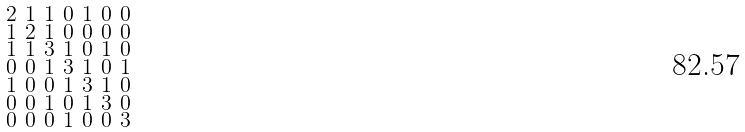<formula> <loc_0><loc_0><loc_500><loc_500>\begin{smallmatrix} 2 & 1 & 1 & 0 & 1 & 0 & 0 \\ 1 & 2 & 1 & 0 & 0 & 0 & 0 \\ 1 & 1 & 3 & 1 & 0 & 1 & 0 \\ 0 & 0 & 1 & 3 & 1 & 0 & 1 \\ 1 & 0 & 0 & 1 & 3 & 1 & 0 \\ 0 & 0 & 1 & 0 & 1 & 3 & 0 \\ 0 & 0 & 0 & 1 & 0 & 0 & 3 \end{smallmatrix}</formula> 